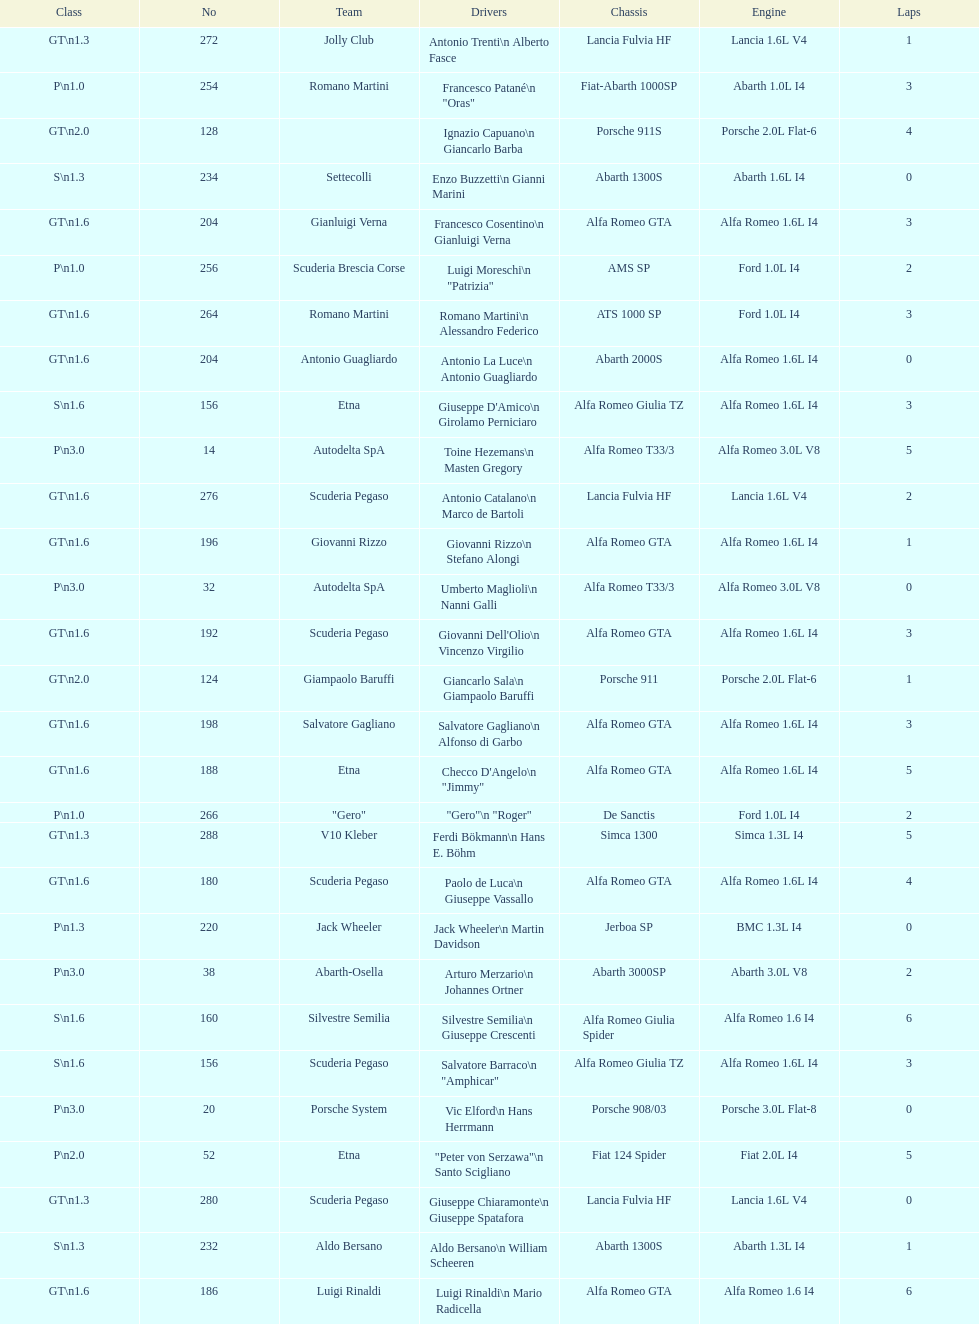What class is below s 1.6? GT 1.6. 